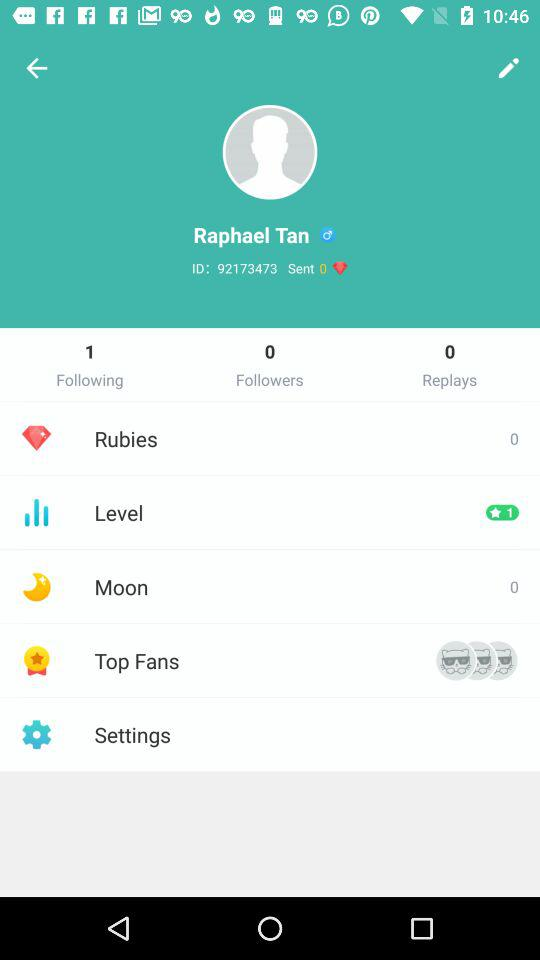What is the user name? The user name is Raphael Tan. 